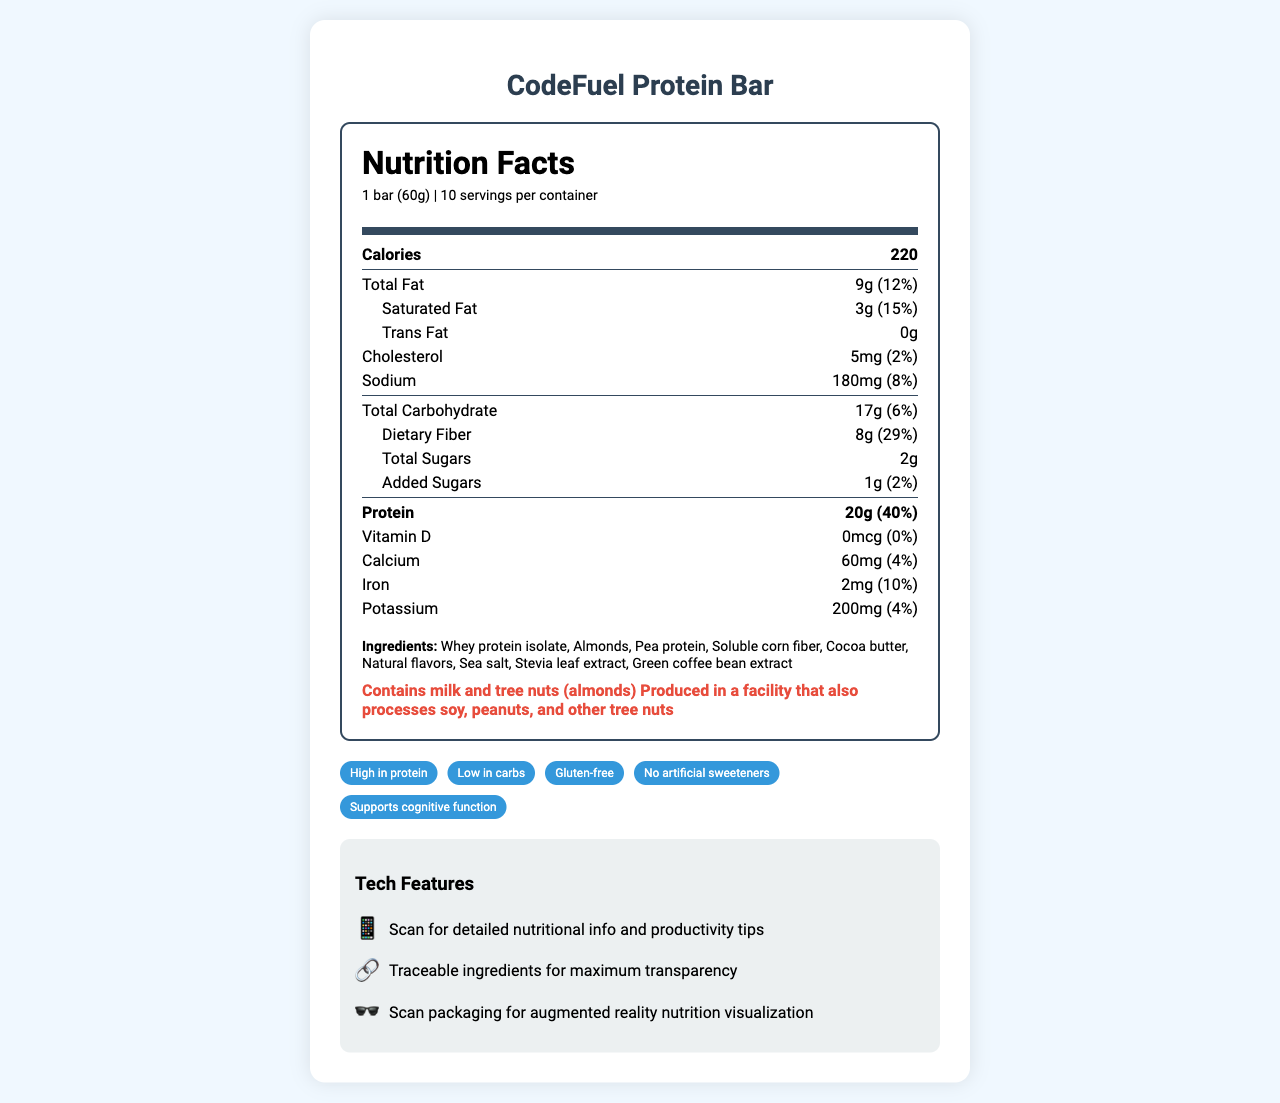what is the total fat content per serving? The document states that the total fat per serving is 9g.
Answer: 9g how much protein is in one CodeFuel Protein Bar? The document lists the protein content per serving as 20g.
Answer: 20g what are the allergens mentioned on the nutrition label? The allergens are explicitly listed under the "allergens" section.
Answer: Contains milk and tree nuts (almonds), Produced in a facility that also processes soy, peanuts, and other tree nuts what is the serving size of the CodeFuel Protein Bar? The serving size is mentioned at the beginning of the document: “1 bar (60g)”.
Answer: 1 bar (60g) which company manufactures the CodeFuel Protein Bar? The manufacturer is mentioned at the end of the document as "TechNutri Foods, Inc."
Answer: TechNutri Foods, Inc. what are the main claims made about the CodeFuel Protein Bar? A. High in protein B. Low in carbs C. Gluten-free D. All of the above The claims section lists "High in protein," "Low in carbs," and "Gluten-free" as claims.
Answer: D how many calories does one CodeFuel Protein Bar contain? A. 180 B. 200 C. 220 D. 250 The document states that the bar contains 220 calories.
Answer: C does the CodeFuel Protein Bar contain any trans fat? It clearly states that the trans fat content is 0g.
Answer: No how does the nutrition label address ingredient transparency? One of the tech features listed is "Traceable ingredients for maximum transparency" using blockchain.
Answer: Uses blockchain technology for traceable ingredients can you scan the packaging for additional information? The document mentions a QR code that can be scanned for detailed nutritional info and productivity tips.
Answer: Yes describe the tech features of the CodeFuel Protein Bar. The tech features section lists the QR code, blockchain, and AR experience as features.
Answer: The bar includes a QR code for detailed nutrition info and productivity tips, blockchain technology for traceable ingredients, and an augmented reality experience for nutrition visualization. what are the added sugars and their daily value? The document indicates the added sugars amount is 1g, with a daily value of 2%.
Answer: 1g, 2% what are some of the main ingredients in the CodeFuel Protein Bar? These ingredients are listed in the "Ingredients" section.
Answer: Whey protein isolate, Almonds, Pea protein, Soluble corn fiber, Cocoa butter is the product high in dietary fiber? The product contains 8g of dietary fiber per serving, which is 29% of the daily value, indicating it is high in dietary fiber.
Answer: Yes how long can you store the CodeFuel Protein Bar? The document specifies a 12-month shelf life under the "expiration" section.
Answer: Best if consumed within 12 months of production date how much vitamin D is in the CodeFuel Protein Bar? The vitamin D content is explicitly listed as 0mcg.
Answer: 0mcg is the document visually clear and well-structured? The document is organized with clear sections for nutritional facts, ingredients, allergens, claims, and tech features, making it easy to navigate and read.
Answer: Yes how many servings are there per container? The document states there are 10 servings per container.
Answer: 10 what are the social media handles for the CodeFuel Protein Bar? The social media section lists Twitter and Instagram handles.
Answer: Twitter: @CodeFuelBar, Instagram: @codefuel_protein does this bar support cognitive function according to the claims? One of the claims mentioned is "Supports cognitive function".
Answer: Yes what is the URL for the CodeFuel Protein Bar website? The document provides the website URL as www.codefuelbar.com
Answer: www.codefuelbar.com what is the expiration date of the CodeFuel Protein Bar? The expiration section only states "Best if consumed within 12 months of production date" without specifying an actual date.
Answer: Cannot be determined 